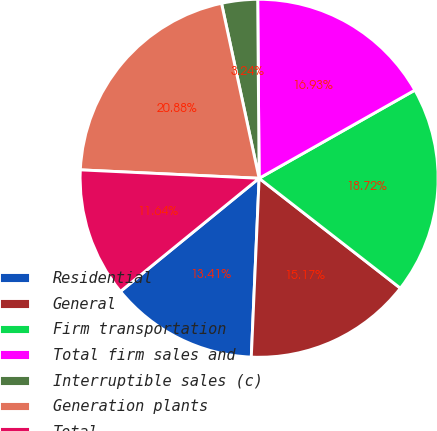<chart> <loc_0><loc_0><loc_500><loc_500><pie_chart><fcel>Residential<fcel>General<fcel>Firm transportation<fcel>Total firm sales and<fcel>Interruptible sales (c)<fcel>Generation plants<fcel>Total<nl><fcel>13.41%<fcel>15.17%<fcel>18.72%<fcel>16.93%<fcel>3.24%<fcel>20.88%<fcel>11.64%<nl></chart> 